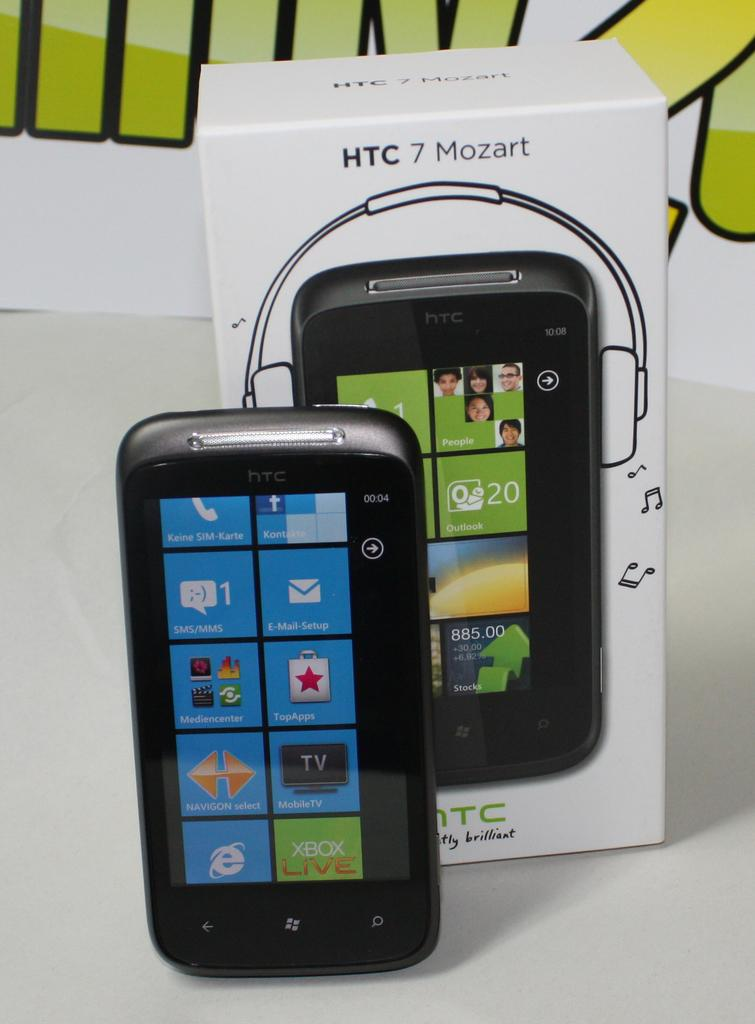Provide a one-sentence caption for the provided image. an HTC 7 Mozart cell phone with box. 